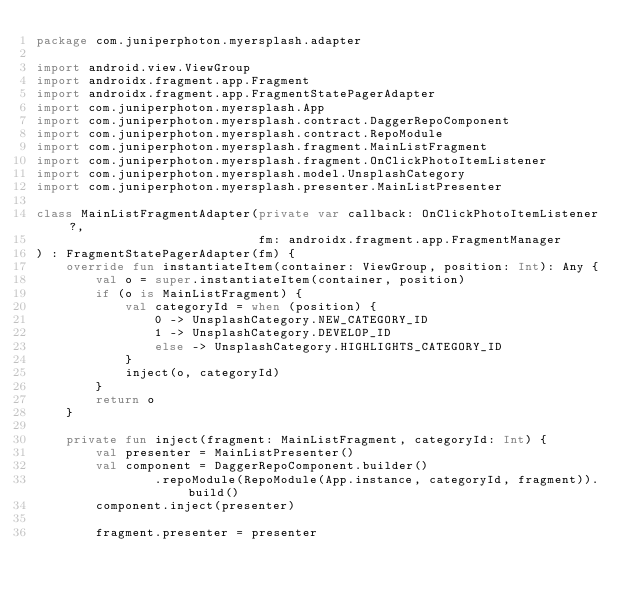<code> <loc_0><loc_0><loc_500><loc_500><_Kotlin_>package com.juniperphoton.myersplash.adapter

import android.view.ViewGroup
import androidx.fragment.app.Fragment
import androidx.fragment.app.FragmentStatePagerAdapter
import com.juniperphoton.myersplash.App
import com.juniperphoton.myersplash.contract.DaggerRepoComponent
import com.juniperphoton.myersplash.contract.RepoModule
import com.juniperphoton.myersplash.fragment.MainListFragment
import com.juniperphoton.myersplash.fragment.OnClickPhotoItemListener
import com.juniperphoton.myersplash.model.UnsplashCategory
import com.juniperphoton.myersplash.presenter.MainListPresenter

class MainListFragmentAdapter(private var callback: OnClickPhotoItemListener?,
                              fm: androidx.fragment.app.FragmentManager
) : FragmentStatePagerAdapter(fm) {
    override fun instantiateItem(container: ViewGroup, position: Int): Any {
        val o = super.instantiateItem(container, position)
        if (o is MainListFragment) {
            val categoryId = when (position) {
                0 -> UnsplashCategory.NEW_CATEGORY_ID
                1 -> UnsplashCategory.DEVELOP_ID
                else -> UnsplashCategory.HIGHLIGHTS_CATEGORY_ID
            }
            inject(o, categoryId)
        }
        return o
    }

    private fun inject(fragment: MainListFragment, categoryId: Int) {
        val presenter = MainListPresenter()
        val component = DaggerRepoComponent.builder()
                .repoModule(RepoModule(App.instance, categoryId, fragment)).build()
        component.inject(presenter)

        fragment.presenter = presenter</code> 